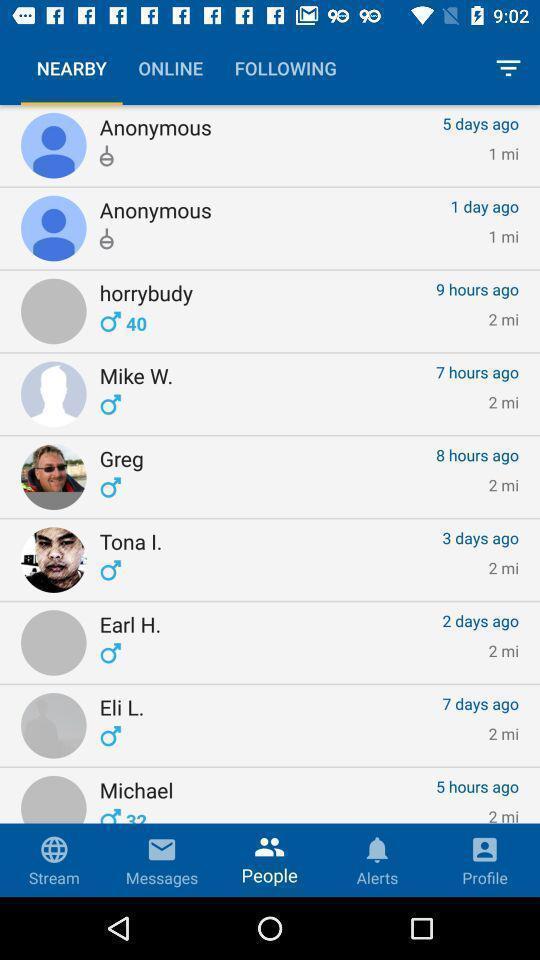Describe the visual elements of this screenshot. Page showings the listings of friends. 